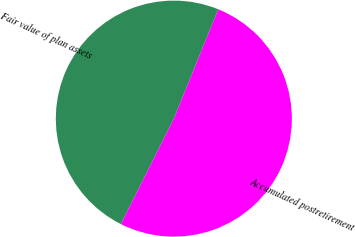Convert chart to OTSL. <chart><loc_0><loc_0><loc_500><loc_500><pie_chart><fcel>Accumulated postretirement<fcel>Fair value of plan assets<nl><fcel>51.28%<fcel>48.72%<nl></chart> 